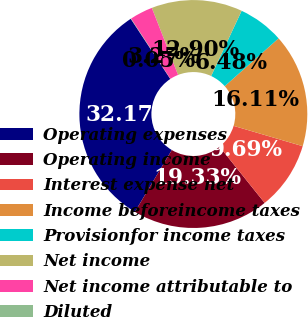Convert chart. <chart><loc_0><loc_0><loc_500><loc_500><pie_chart><fcel>Operating expenses<fcel>Operating income<fcel>Interest expense net<fcel>Income beforeincome taxes<fcel>Provisionfor income taxes<fcel>Net income<fcel>Net income attributable to<fcel>Diluted<nl><fcel>32.17%<fcel>19.33%<fcel>9.69%<fcel>16.11%<fcel>6.48%<fcel>12.9%<fcel>3.27%<fcel>0.05%<nl></chart> 